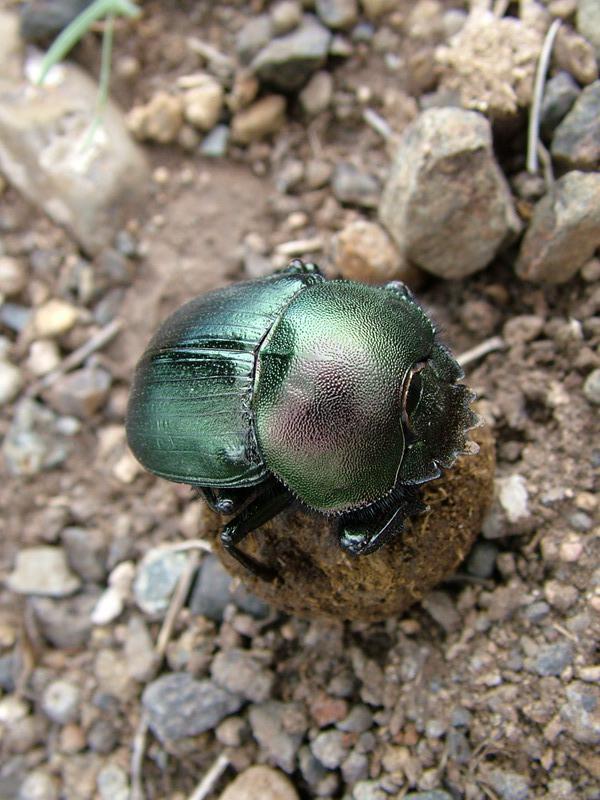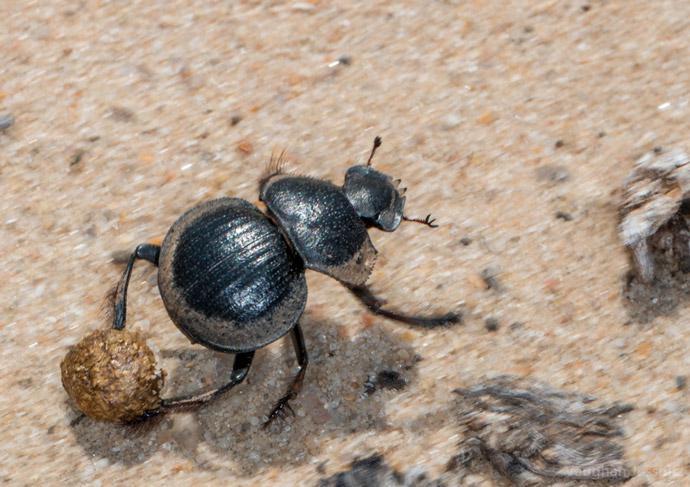The first image is the image on the left, the second image is the image on the right. For the images shown, is this caption "In each image, there are two beetles holding a dungball.›" true? Answer yes or no. No. The first image is the image on the left, the second image is the image on the right. For the images displayed, is the sentence "The right image has two beetles pushing a dung ball." factually correct? Answer yes or no. No. 